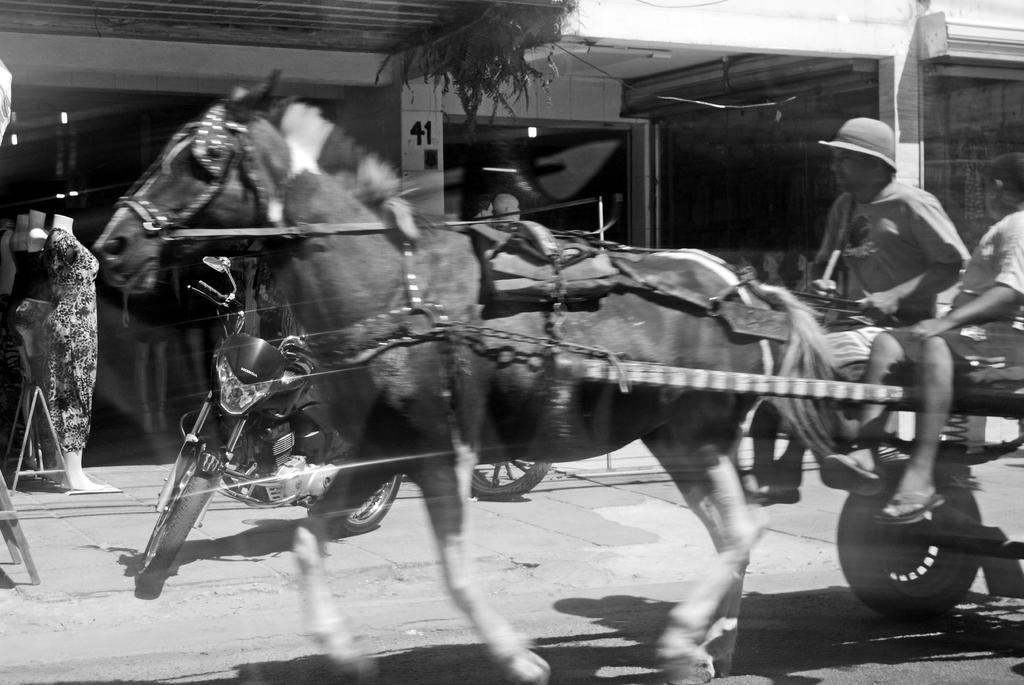Describe this image in one or two sentences. This is a black and white image in which we can see two people riding a horse cart. On the backside we can see a motor vehicle, plants, the mannequins and a building. 